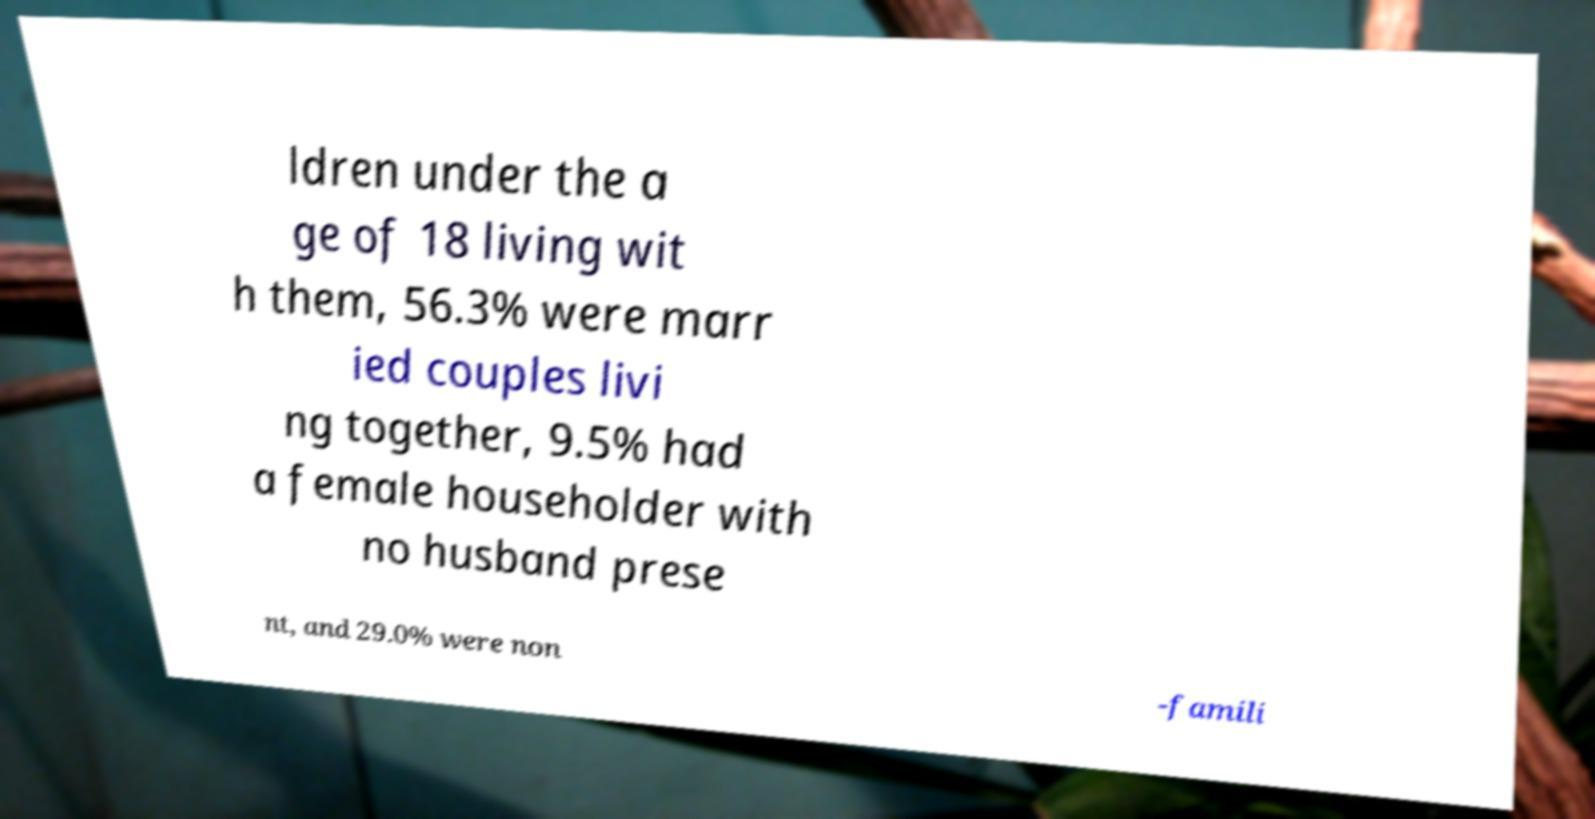For documentation purposes, I need the text within this image transcribed. Could you provide that? ldren under the a ge of 18 living wit h them, 56.3% were marr ied couples livi ng together, 9.5% had a female householder with no husband prese nt, and 29.0% were non -famili 